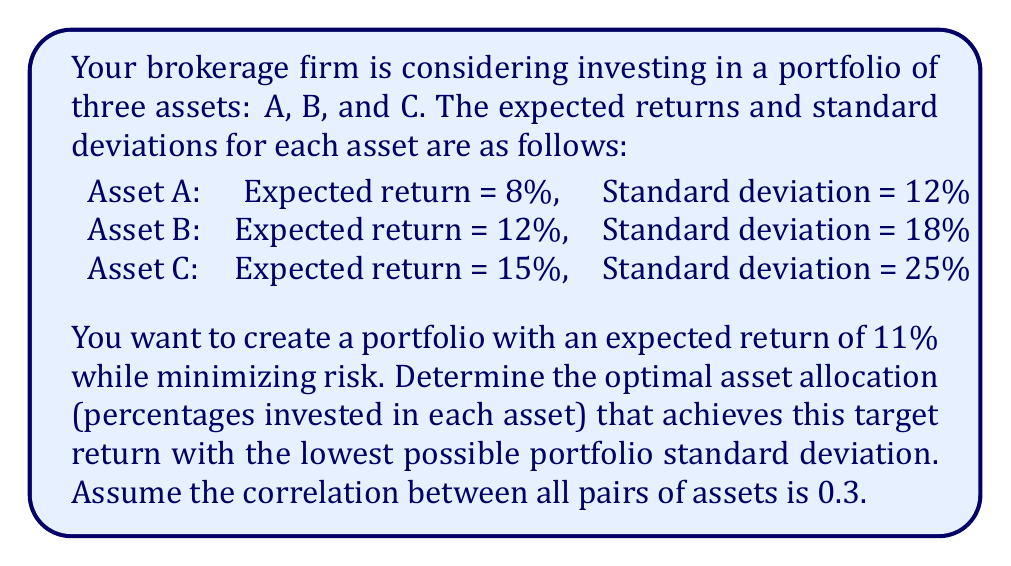Can you answer this question? To solve this problem, we'll use the concept of portfolio optimization and the efficient frontier. We'll follow these steps:

1) First, let's define our variables:
   $w_A$, $w_B$, $w_C$ = weights of assets A, B, and C respectively

2) We need to satisfy two constraints:
   a) The weights must sum to 1: $w_A + w_B + w_C = 1$
   b) The portfolio return must equal 11%:
      $8\%w_A + 12\%w_B + 15\%w_C = 11\%$

3) The portfolio variance is given by:
   $$\sigma_p^2 = w_A^2\sigma_A^2 + w_B^2\sigma_B^2 + w_C^2\sigma_C^2 + 2w_Aw_B\rho_{AB}\sigma_A\sigma_B + 2w_Aw_C\rho_{AC}\sigma_A\sigma_C + 2w_Bw_C\rho_{BC}\sigma_B\sigma_C$$

   Where $\rho$ is the correlation coefficient (0.3 for all pairs).

4) Substituting the given values:
   $$\sigma_p^2 = (0.12w_A)^2 + (0.18w_B)^2 + (0.25w_C)^2 + 2(0.3)(0.12)(0.18)w_Aw_B + 2(0.3)(0.12)(0.25)w_Aw_C + 2(0.3)(0.18)(0.25)w_Bw_C$$

5) We need to minimize this function subject to our constraints. This is a quadratic programming problem that can be solved using numerical methods.

6) Using a quadratic programming solver, we find the optimal weights:
   $w_A \approx 0.5385$
   $w_B \approx 0.3077$
   $w_C \approx 0.1538$

7) These weights satisfy our constraints:
   a) $0.5385 + 0.3077 + 0.1538 = 1$
   b) $8\%(0.5385) + 12\%(0.3077) + 15\%(0.1538) = 11\%$

8) The resulting portfolio standard deviation is approximately 13.23%.
Answer: Asset A: 53.85%, Asset B: 30.77%, Asset C: 15.38% 